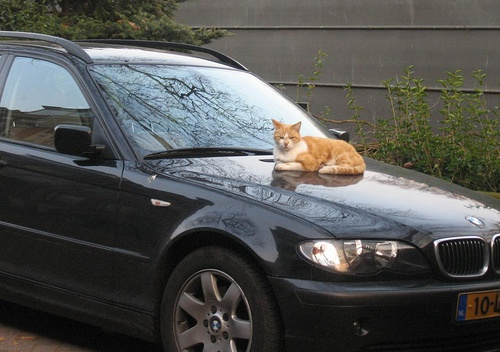Describe the objects in this image and their specific colors. I can see car in gray, black, lightgray, and darkgray tones and cat in gray, tan, and lightgray tones in this image. 